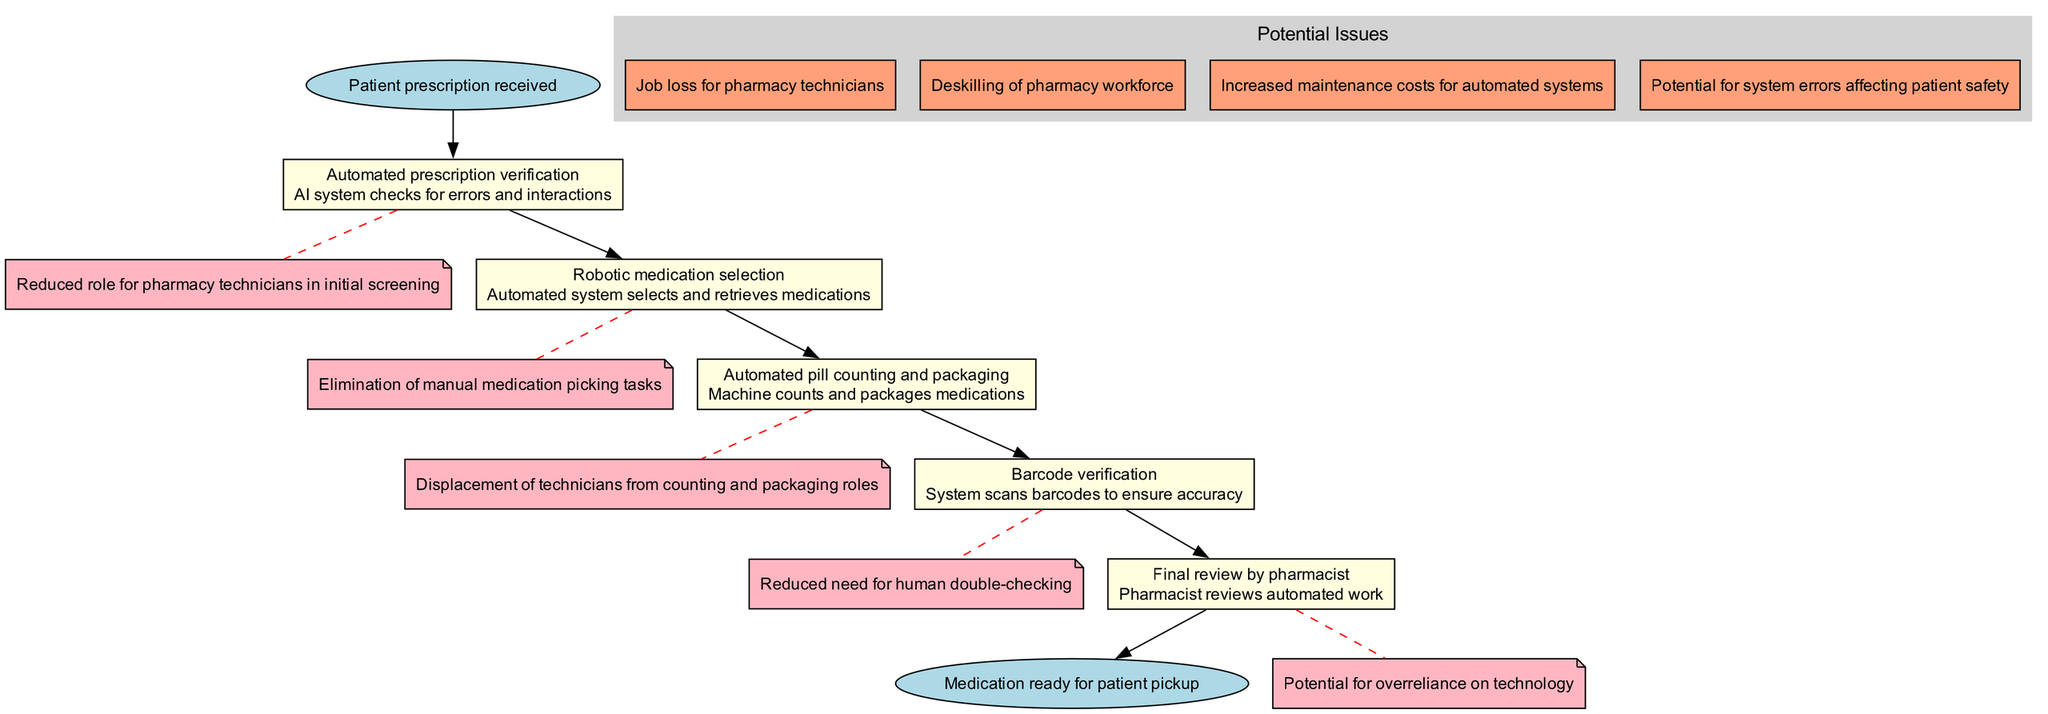What is the starting point of the clinical pathway? The starting point, as indicated in the diagram, is "Patient prescription received."
Answer: Patient prescription received What step follows "Automated prescription verification"? The next step, following "Automated prescription verification," is "Robotic medication selection." This is established by the connecting edges in the diagram.
Answer: Robotic medication selection How many steps are included in the clinical pathway? There are five steps listed in the clinical pathway, each representing a distinct task in the process.
Answer: 5 What are the potential issues listed in the diagram? The diagram outlines several potential issues, including “Job loss for pharmacy technicians,” “Deskilling of pharmacy workforce,” “Increased maintenance costs for automated systems,” and “Potential for system errors affecting patient safety.”
Answer: Job loss for pharmacy technicians, Deskilling of pharmacy workforce, Increased maintenance costs for automated systems, Potential for system errors affecting patient safety What is the concern associated with "Automated pill counting and packaging"? The concern presented in the diagram is "Displacement of technicians from counting and packaging roles.” This is specifically noted for this step and indicates a significant impact on job roles.
Answer: Displacement of technicians from counting and packaging roles Which step has the concern of "Potential for overreliance on technology"? This concern is associated with the "Final review by pharmacist" step, as indicated by the note linked to this step in the diagram.
Answer: Final review by pharmacist What is the endpoint of the clinical pathway? The endpoint of the clinical pathway is "Medication ready for patient pickup," as identified at the end of the flow in the diagram.
Answer: Medication ready for patient pickup What type of tasks are automated in "Robotic medication selection"? The task automated here is the selection and retrieval of medications, which eliminates manual processes for pharmacy technicians.
Answer: Selection and retrieval of medications What does the "Barcode verification" step ensure? The "Barcode verification" step ensures accuracy by scanning barcodes, which reduces the human need for double-checking medication accuracy.
Answer: Ensures accuracy by scanning barcodes 